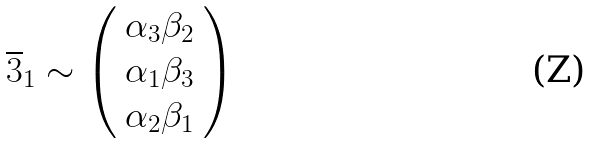<formula> <loc_0><loc_0><loc_500><loc_500>\overline { 3 } _ { 1 } \sim \left ( \begin{array} { c } \alpha _ { 3 } \beta _ { 2 } \\ \alpha _ { 1 } \beta _ { 3 } \\ \alpha _ { 2 } \beta _ { 1 } \\ \end{array} \right )</formula> 